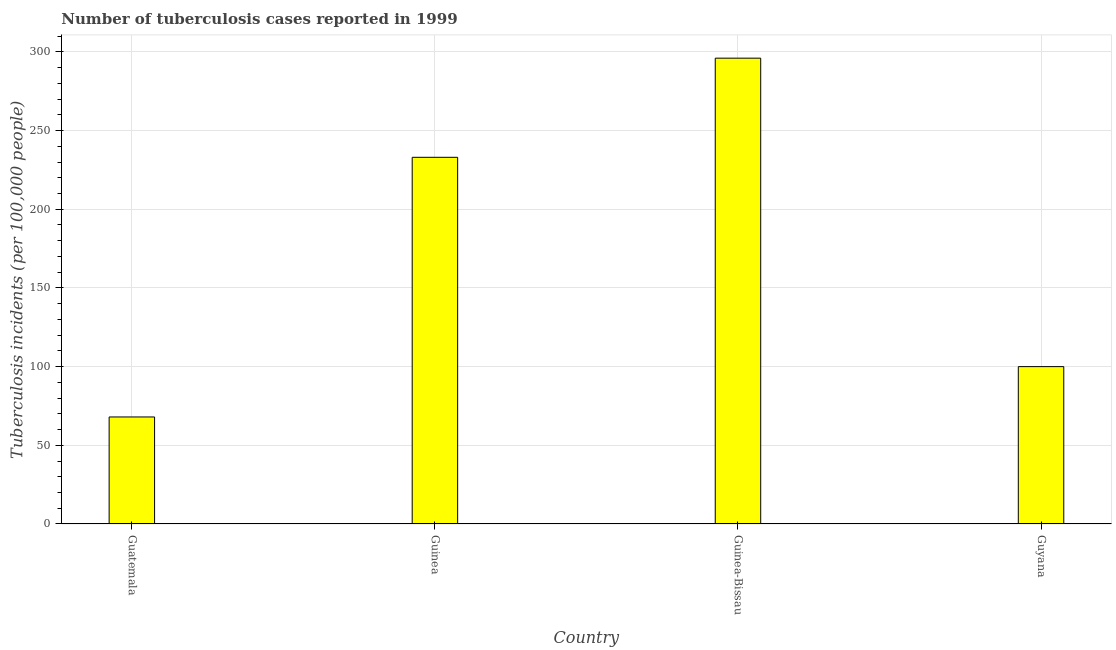Does the graph contain grids?
Give a very brief answer. Yes. What is the title of the graph?
Provide a succinct answer. Number of tuberculosis cases reported in 1999. What is the label or title of the X-axis?
Offer a very short reply. Country. What is the label or title of the Y-axis?
Ensure brevity in your answer.  Tuberculosis incidents (per 100,0 people). Across all countries, what is the maximum number of tuberculosis incidents?
Provide a short and direct response. 296. In which country was the number of tuberculosis incidents maximum?
Make the answer very short. Guinea-Bissau. In which country was the number of tuberculosis incidents minimum?
Give a very brief answer. Guatemala. What is the sum of the number of tuberculosis incidents?
Ensure brevity in your answer.  697. What is the difference between the number of tuberculosis incidents in Guatemala and Guyana?
Give a very brief answer. -32. What is the average number of tuberculosis incidents per country?
Provide a short and direct response. 174.25. What is the median number of tuberculosis incidents?
Give a very brief answer. 166.5. In how many countries, is the number of tuberculosis incidents greater than 290 ?
Your response must be concise. 1. What is the ratio of the number of tuberculosis incidents in Guinea to that in Guyana?
Your answer should be very brief. 2.33. Is the difference between the number of tuberculosis incidents in Guatemala and Guyana greater than the difference between any two countries?
Ensure brevity in your answer.  No. Is the sum of the number of tuberculosis incidents in Guatemala and Guyana greater than the maximum number of tuberculosis incidents across all countries?
Your answer should be very brief. No. What is the difference between the highest and the lowest number of tuberculosis incidents?
Make the answer very short. 228. How many bars are there?
Ensure brevity in your answer.  4. What is the difference between two consecutive major ticks on the Y-axis?
Your response must be concise. 50. What is the Tuberculosis incidents (per 100,000 people) of Guinea?
Give a very brief answer. 233. What is the Tuberculosis incidents (per 100,000 people) in Guinea-Bissau?
Your response must be concise. 296. What is the Tuberculosis incidents (per 100,000 people) of Guyana?
Keep it short and to the point. 100. What is the difference between the Tuberculosis incidents (per 100,000 people) in Guatemala and Guinea?
Your response must be concise. -165. What is the difference between the Tuberculosis incidents (per 100,000 people) in Guatemala and Guinea-Bissau?
Offer a terse response. -228. What is the difference between the Tuberculosis incidents (per 100,000 people) in Guatemala and Guyana?
Provide a succinct answer. -32. What is the difference between the Tuberculosis incidents (per 100,000 people) in Guinea and Guinea-Bissau?
Offer a terse response. -63. What is the difference between the Tuberculosis incidents (per 100,000 people) in Guinea and Guyana?
Provide a succinct answer. 133. What is the difference between the Tuberculosis incidents (per 100,000 people) in Guinea-Bissau and Guyana?
Make the answer very short. 196. What is the ratio of the Tuberculosis incidents (per 100,000 people) in Guatemala to that in Guinea?
Your response must be concise. 0.29. What is the ratio of the Tuberculosis incidents (per 100,000 people) in Guatemala to that in Guinea-Bissau?
Keep it short and to the point. 0.23. What is the ratio of the Tuberculosis incidents (per 100,000 people) in Guatemala to that in Guyana?
Ensure brevity in your answer.  0.68. What is the ratio of the Tuberculosis incidents (per 100,000 people) in Guinea to that in Guinea-Bissau?
Offer a very short reply. 0.79. What is the ratio of the Tuberculosis incidents (per 100,000 people) in Guinea to that in Guyana?
Your answer should be compact. 2.33. What is the ratio of the Tuberculosis incidents (per 100,000 people) in Guinea-Bissau to that in Guyana?
Make the answer very short. 2.96. 